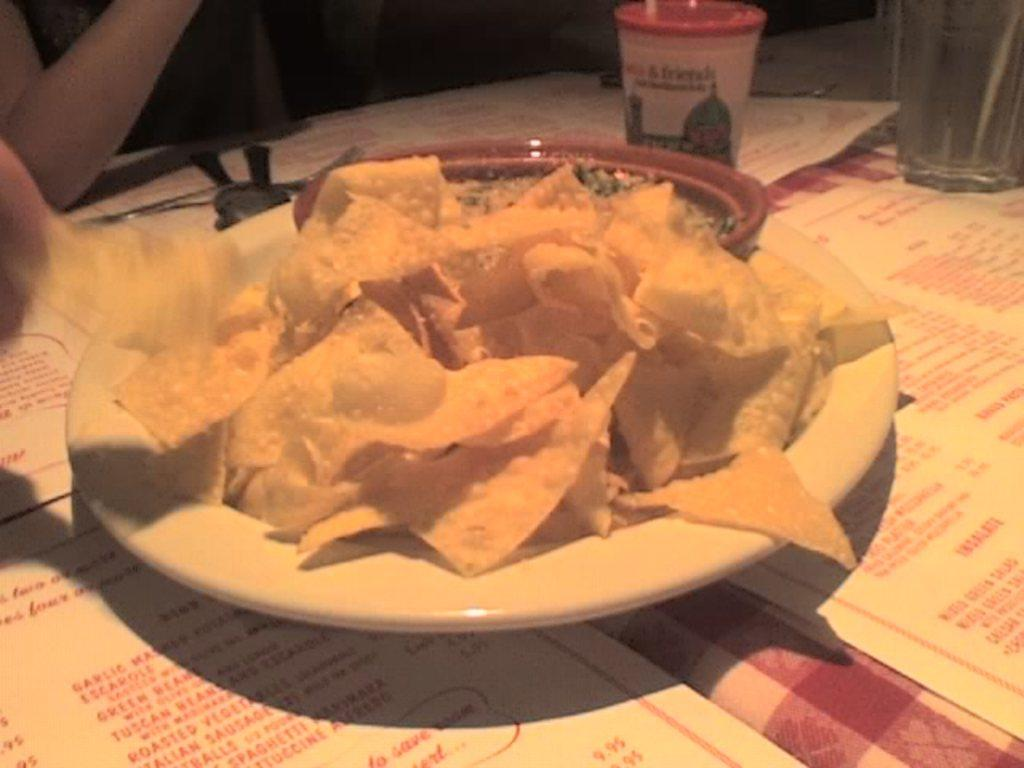Who is present in the image? There is a woman in the image. What is the woman doing in the image? The woman is sitting near a table. What food items can be seen on the table? There is a plate with chips and a cup on the table. What beverage is present on the table? There is a water glass on the table. What type of vest is the woman wearing in the image? The image does not show the woman wearing a vest, so it cannot be determined from the image. 